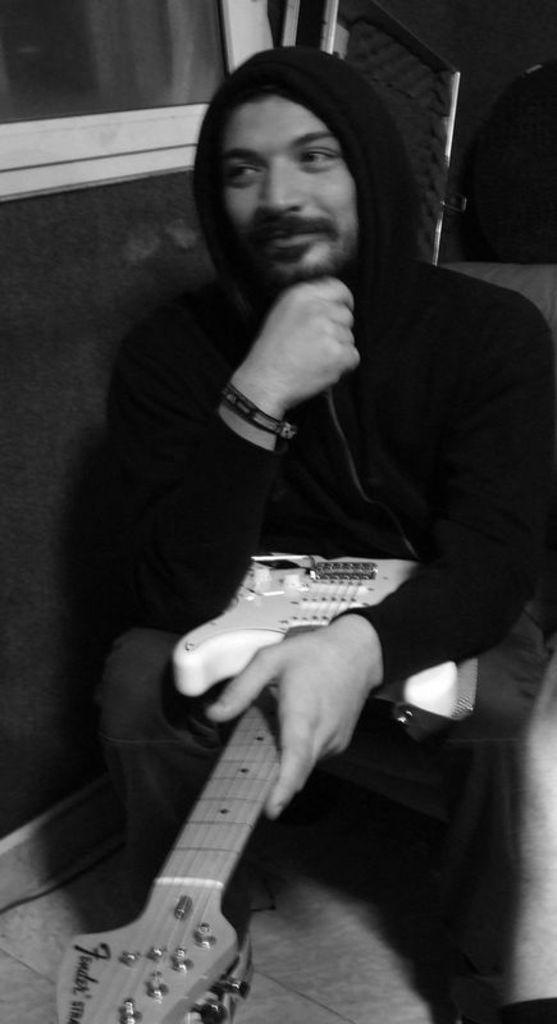What is the main subject of the image? There is a person in the image. What is the person doing in the image? The person is sitting in a squat position and holding a guitar. What type of clothing is the person wearing? The person is wearing a cap. What type of drum is the person playing in the image? There is no drum present in the image; the person is holding a guitar. How is the person connected to the guitar in the image? The person is holding the guitar in their hands, which establishes a physical connection between the person and the guitar. 